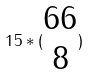<formula> <loc_0><loc_0><loc_500><loc_500>1 5 * ( \begin{matrix} 6 6 \\ 8 \end{matrix} )</formula> 